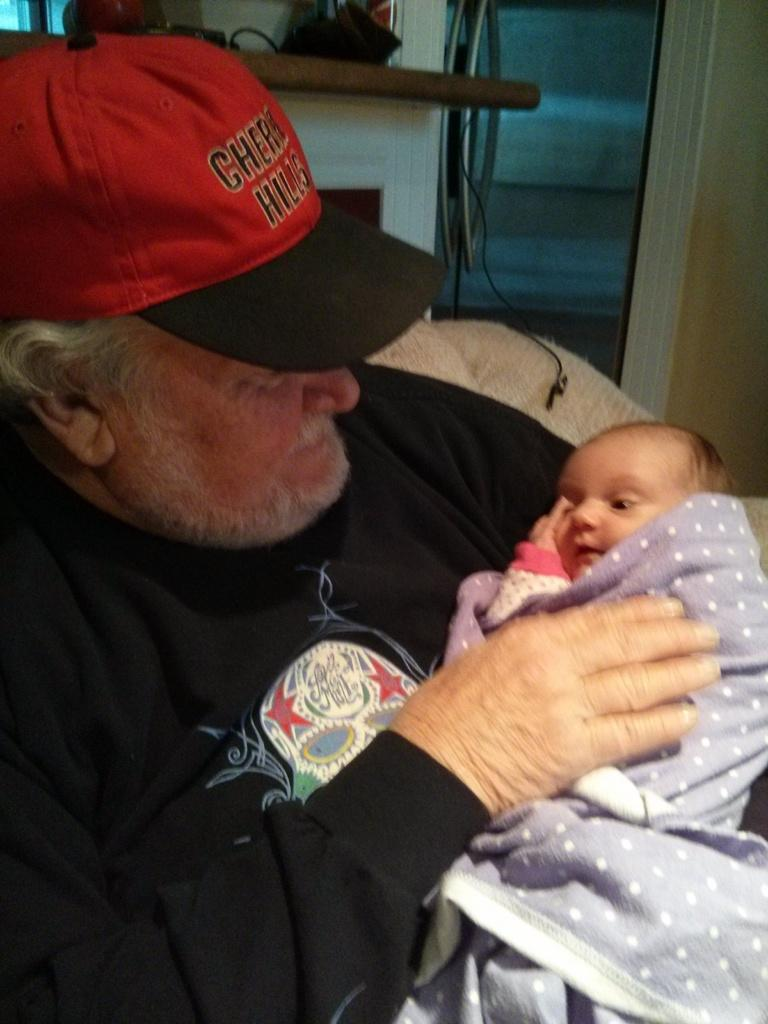<image>
Relay a brief, clear account of the picture shown. A man is holding a baby and his hat says Cherry Hills. 